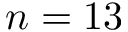Convert formula to latex. <formula><loc_0><loc_0><loc_500><loc_500>n = 1 3</formula> 